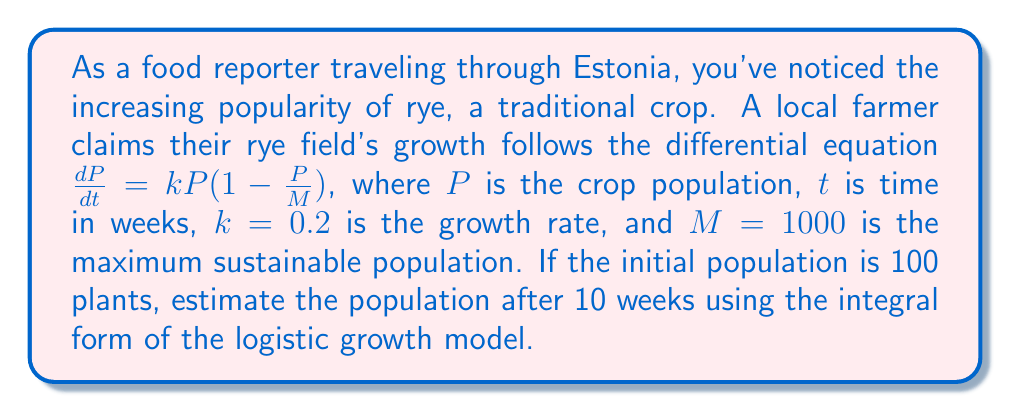Could you help me with this problem? To solve this problem, we'll follow these steps:

1) The logistic growth model is given by the differential equation:

   $$\frac{dP}{dt} = kP(1-\frac{P}{M})$$

2) The integral form of this equation is:

   $$\int_{P_0}^P \frac{dP}{P(1-\frac{P}{M})} = \int_0^t k dt$$

3) Solving the left side of the equation:

   $$\left[\ln|P| + M\ln|1-\frac{P}{M}|\right]_{P_0}^P = kt$$

4) Substituting the given values ($P_0=100$, $M=1000$, $k=0.2$, $t=10$):

   $$\ln|\frac{P}{100}| + 1000\ln|\frac{900-P}{900}| = 2$$

5) This equation can't be solved algebraically, so we need to use numerical methods. Using a graphing calculator or computer software, we can find that:

   $$P \approx 352.65$$

6) Rounding to the nearest whole number (as we're dealing with plants):

   $$P \approx 353$$

Thus, after 10 weeks, the estimated rye population is approximately 353 plants.
Answer: 353 plants 